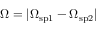Convert formula to latex. <formula><loc_0><loc_0><loc_500><loc_500>\Omega = | \Omega _ { s p 1 } - \Omega _ { s p 2 } |</formula> 